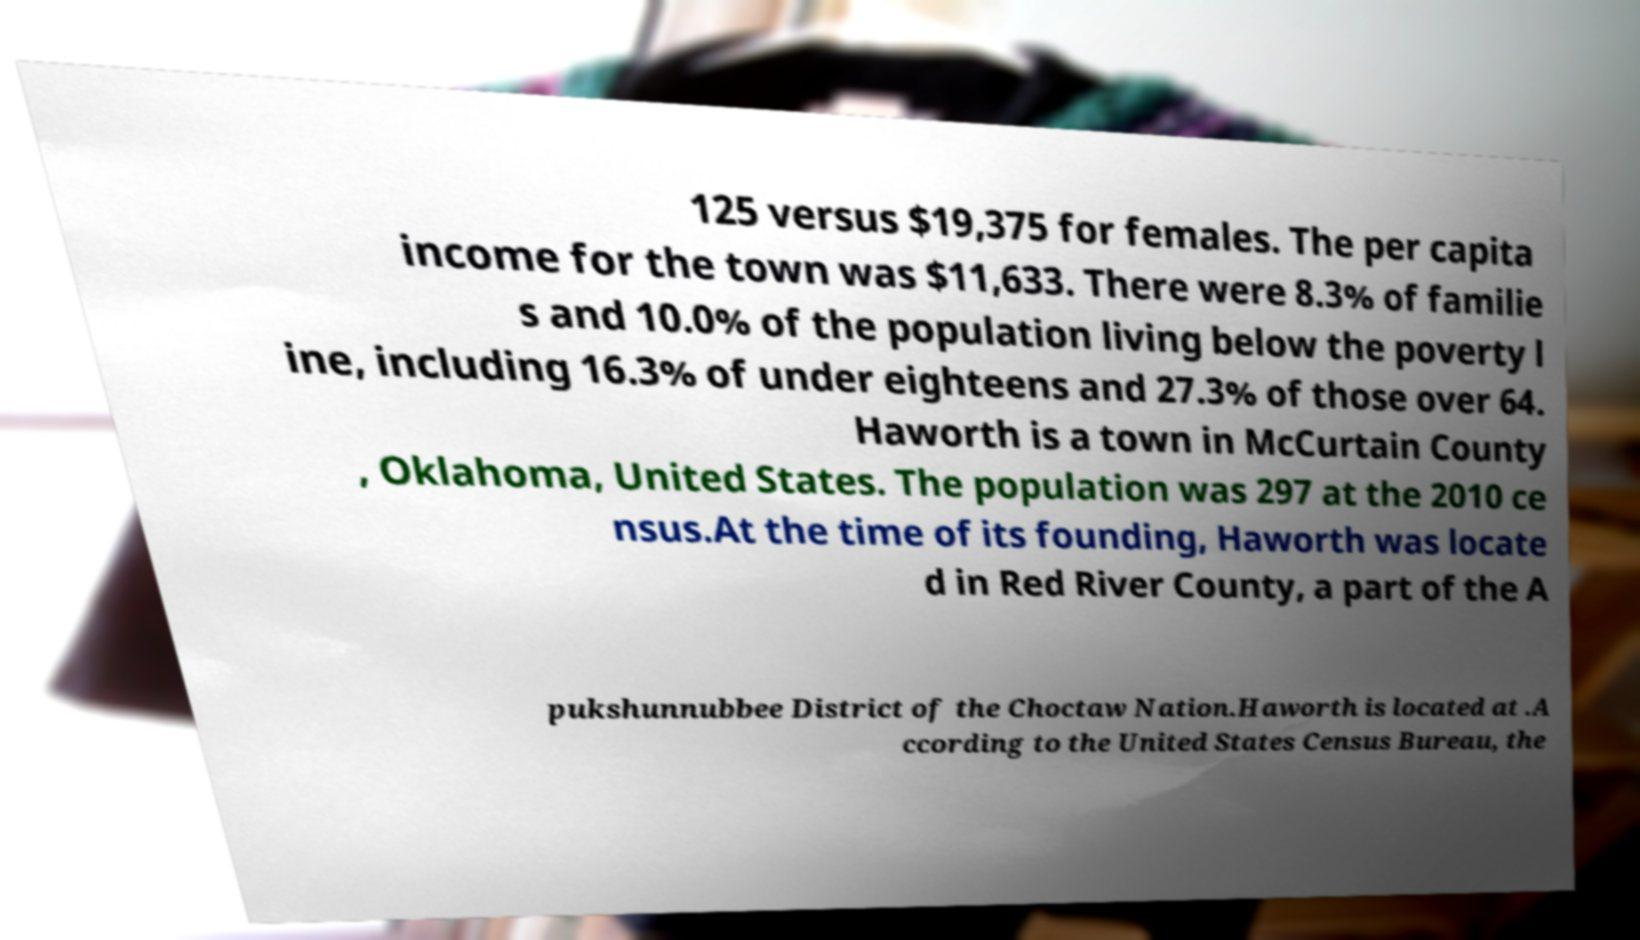Can you accurately transcribe the text from the provided image for me? 125 versus $19,375 for females. The per capita income for the town was $11,633. There were 8.3% of familie s and 10.0% of the population living below the poverty l ine, including 16.3% of under eighteens and 27.3% of those over 64. Haworth is a town in McCurtain County , Oklahoma, United States. The population was 297 at the 2010 ce nsus.At the time of its founding, Haworth was locate d in Red River County, a part of the A pukshunnubbee District of the Choctaw Nation.Haworth is located at .A ccording to the United States Census Bureau, the 